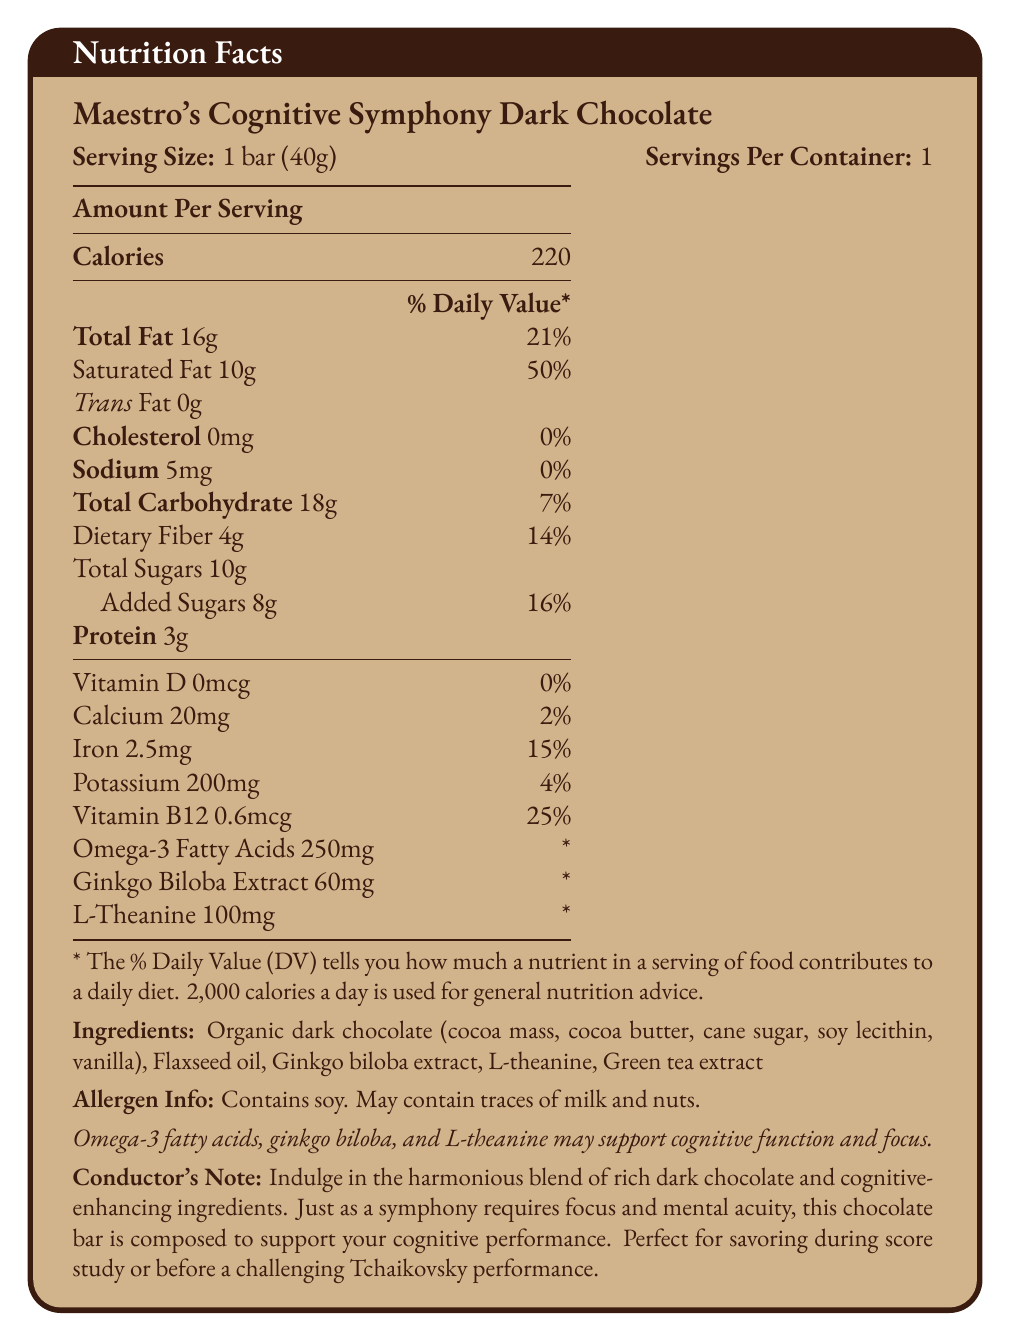What is the serving size of Maestro's Cognitive Symphony Dark Chocolate? The serving size is explicitly stated as "1 bar (40g)" in the document.
Answer: 1 bar (40g) How many calories does one serving of this chocolate bar contain? The document lists the amount of calories per serving as "220."
Answer: 220 What is the percentage of the daily value of saturated fat in one serving? The document indicates that the saturated fat content is 10g, which is 50% of the daily value.
Answer: 50% Which ingredient is described as an allergen in this chocolate bar? The label states "Contains soy. May contain traces of milk and nuts."
Answer: Soy How much protein is in one serving of this chocolate bar? The document specifies that one serving contains 3g of protein.
Answer: 3g What are the main cognitive-enhancing ingredients listed in this chocolate bar? The document highlights these ingredients and states their contributions to cognitive function and focus.
Answer: Omega-3 fatty acids, Ginkgo biloba extract, L-theanine Which vitamin has the highest daily value percentage in this chocolate bar? The document lists Vitamin B12 with a 25% daily value, which is the highest among the vitamins mentioned.
Answer: Vitamin B12 Is there any form of trans fat present in this chocolate bar? The document states "Trans Fat 0g."
Answer: No Which of the following statements is true about the sugar content in one serving?
A. It has 4g of added sugars.
B. It has a total of 10g of sugars, with 8g added sugars.
C. It contains more added sugars than total sugars. Option B is correct as the document specifies "Total Sugars 10g" and "Added Sugars 8g."
Answer: B What is the daily value percentage of dietary fiber in one serving of this chocolate bar?
A. 7%
B. 14%
C. 16%
D. 21% The document states that dietary fiber is 4g per serving, which is 14% of the daily value.
Answer: B Does this chocolate bar contain any cholesterol? The document lists "Cholesterol 0mg."
Answer: No Summarize the key features of Maestro's Cognitive Symphony Dark Chocolate. The summary encapsulates the nutritional information, cognitive-enhancing ingredients, serving size, and allergen information provided in the document.
Answer: Maestro's Cognitive Symphony Dark Chocolate is designed to enhance cognitive function with ingredients like Omega-3 fatty acids, Ginkgo biloba extract, and L-theanine. Each bar (40g) contains 220 calories, 16g total fat, 10g saturated fat, 18g total carbohydrates with 4g dietary fiber and 8g added sugars, and 3g protein. It includes essential nutrients such as Vitamin B12 (25% DV) and iron (15% DV). The chocolate is free from cholesterol, contains minimal sodium, and may help improve focus and mental acuity. It's also noted for its allergen content, including soy, and possible traces of milk and nuts. What is the amount of omega-3 fatty acids in each serving of this chocolate bar? The document specifies that each serving contains 250mg of omega-3 fatty acids.
Answer: 250mg How many servings are there in one container of Maestro's Cognitive Symphony Dark Chocolate? The document clearly states "Servings Per Container: 1."
Answer: 1 What are the additional nutrients listed in this chocolate bar that are linked to cognitive function? The document includes these nutrients in addition to omega-3 fatty acids, highlighting their role in cognitive function.
Answer: Ginkgo biloba extract and L-theanine How much iron does one serving of this chocolate bar provide? The document lists the amount of iron in one serving as 2.5mg.
Answer: 2.5mg Is there any information on the origin of the cocoa in this chocolate bar? The document mentions "organic dark chocolate" but does not provide detailed information on the origin of the cocoa.
Answer: Not enough information 